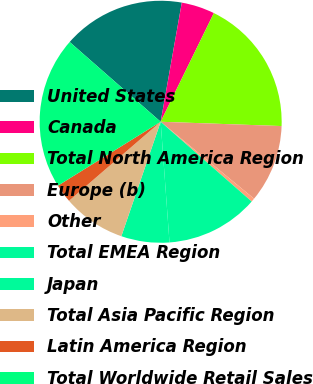Convert chart to OTSL. <chart><loc_0><loc_0><loc_500><loc_500><pie_chart><fcel>United States<fcel>Canada<fcel>Total North America Region<fcel>Europe (b)<fcel>Other<fcel>Total EMEA Region<fcel>Japan<fcel>Total Asia Pacific Region<fcel>Latin America Region<fcel>Total Worldwide Retail Sales<nl><fcel>16.34%<fcel>4.45%<fcel>18.32%<fcel>10.4%<fcel>0.49%<fcel>12.38%<fcel>6.43%<fcel>8.41%<fcel>2.47%<fcel>20.31%<nl></chart> 